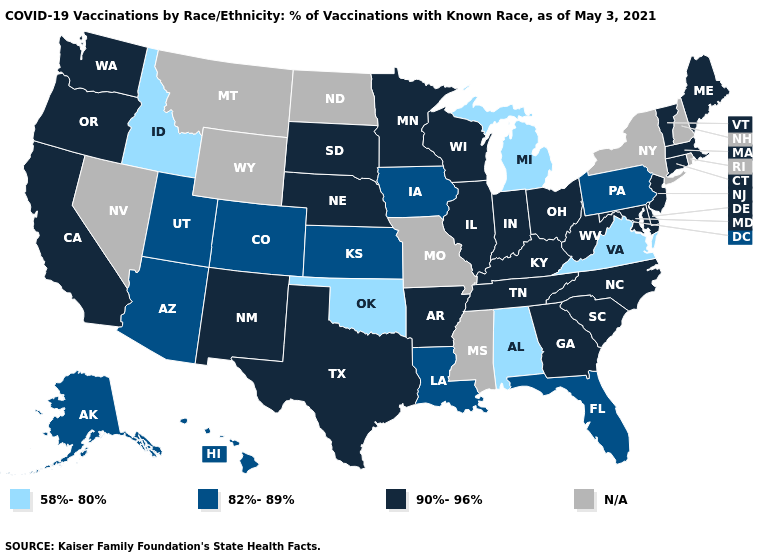Which states have the lowest value in the USA?
Be succinct. Alabama, Idaho, Michigan, Oklahoma, Virginia. Does the first symbol in the legend represent the smallest category?
Be succinct. Yes. What is the value of Oregon?
Answer briefly. 90%-96%. How many symbols are there in the legend?
Answer briefly. 4. Among the states that border Washington , does Idaho have the lowest value?
Concise answer only. Yes. Name the states that have a value in the range N/A?
Short answer required. Mississippi, Missouri, Montana, Nevada, New Hampshire, New York, North Dakota, Rhode Island, Wyoming. Does Massachusetts have the lowest value in the USA?
Write a very short answer. No. Among the states that border Delaware , which have the highest value?
Short answer required. Maryland, New Jersey. Does California have the highest value in the USA?
Quick response, please. Yes. Name the states that have a value in the range 82%-89%?
Short answer required. Alaska, Arizona, Colorado, Florida, Hawaii, Iowa, Kansas, Louisiana, Pennsylvania, Utah. Name the states that have a value in the range N/A?
Keep it brief. Mississippi, Missouri, Montana, Nevada, New Hampshire, New York, North Dakota, Rhode Island, Wyoming. Does the first symbol in the legend represent the smallest category?
Quick response, please. Yes. Among the states that border New Jersey , does Pennsylvania have the highest value?
Concise answer only. No. Does the map have missing data?
Be succinct. Yes. 